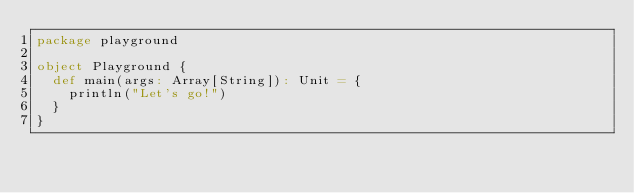Convert code to text. <code><loc_0><loc_0><loc_500><loc_500><_Scala_>package playground

object Playground {
  def main(args: Array[String]): Unit = {
    println("Let's go!")
  }
}
</code> 